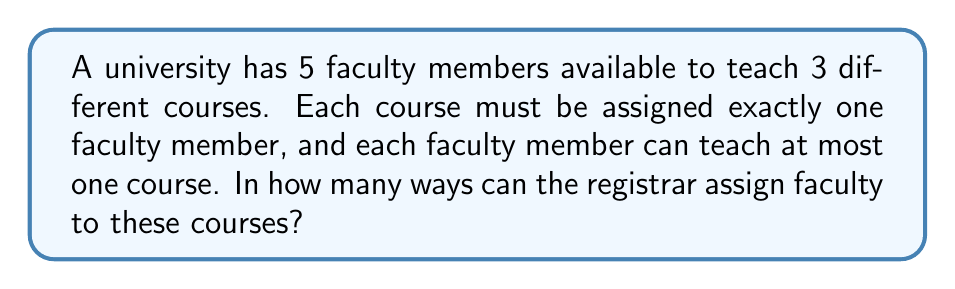What is the answer to this math problem? Let's approach this step-by-step:

1) First, we need to recognize that this is a permutation problem. We are selecting 3 faculty members out of 5 and arranging them in a specific order (as each course is distinct).

2) The formula for permutations is:

   $$P(n,r) = \frac{n!}{(n-r)!}$$

   Where $n$ is the total number of items to choose from, and $r$ is the number of items being chosen.

3) In this case:
   $n = 5$ (total number of faculty members)
   $r = 3$ (number of courses to be assigned)

4) Plugging these values into our formula:

   $$P(5,3) = \frac{5!}{(5-3)!} = \frac{5!}{2!}$$

5) Let's calculate this:
   
   $$\frac{5!}{2!} = \frac{5 \times 4 \times 3 \times 2!}{2!} = 5 \times 4 \times 3 = 60$$

6) Therefore, there are 60 possible ways to assign the faculty to these courses.

This calculation helps the registrar understand the number of possible teaching assignments, which can be useful for planning and resource allocation.
Answer: 60 